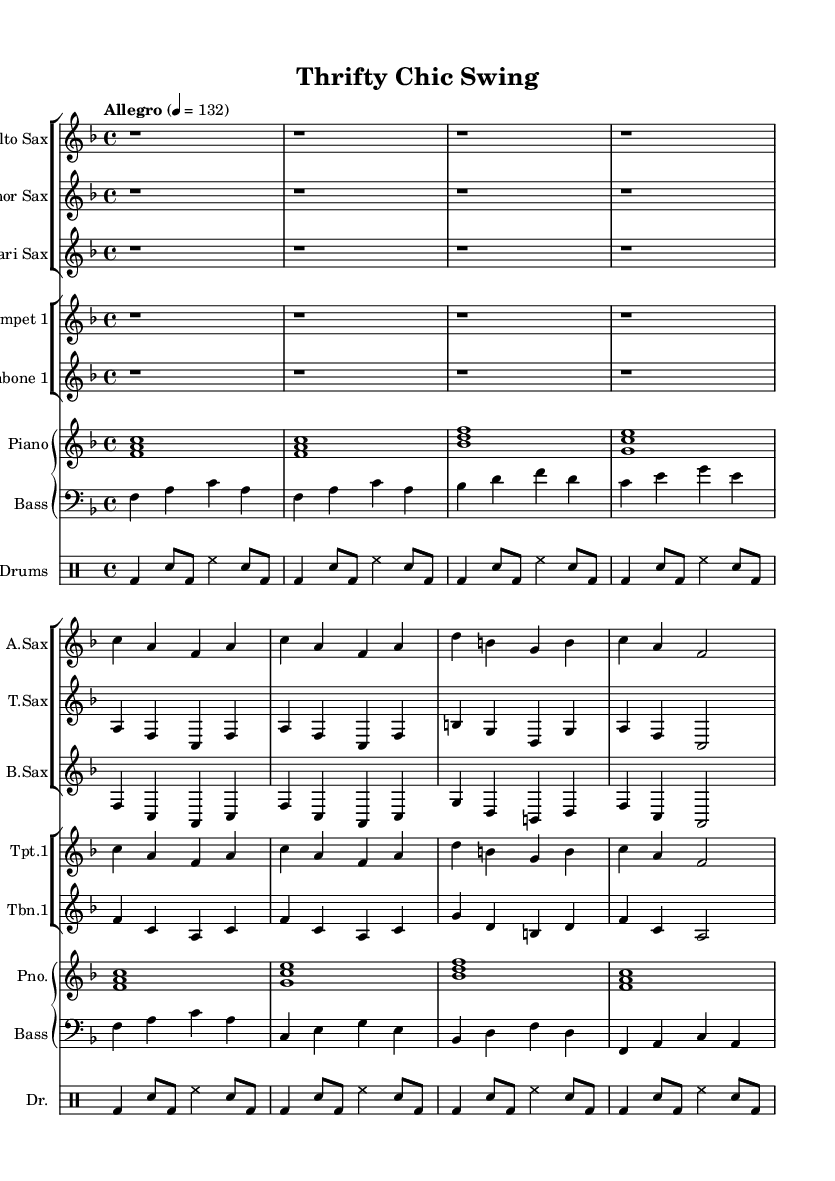What is the key signature of this music? The key signature shown in the sheet music indicates that there are one flat, which is B flat, meaning it is in F major.
Answer: F major What is the time signature of this music? The time signature is indicated at the beginning of the score as 4/4, which means there are four beats per measure.
Answer: 4/4 What is the tempo marking for this piece? The tempo marking "Allegro" is provided at the start, with a metronome marking of quarter note = 132, indicating a fast and lively pace.
Answer: Allegro How many different saxophone parts are indicated in the sheet music? There are three different saxophone parts listed: Alto Sax, Tenor Sax, and Bari Sax.
Answer: Three What instruments are included in the big band arrangement? The sheet music includes Alto Sax, Tenor Sax, Bari Sax, Trumpet 1, Trombone 1, Piano, Bass, and Drums.
Answer: Eight Which instruments play the chord voicings in the score? The Piano part is indicated to play the chord voicings, as shown by the chord symbols written underneath the staff.
Answer: Piano What is the primary function of the drum part in this arrangement? The drum part is indicated to keep the rhythm and drive the tempo forward with its pattern of bass drum and snare hits.
Answer: Rhythm 